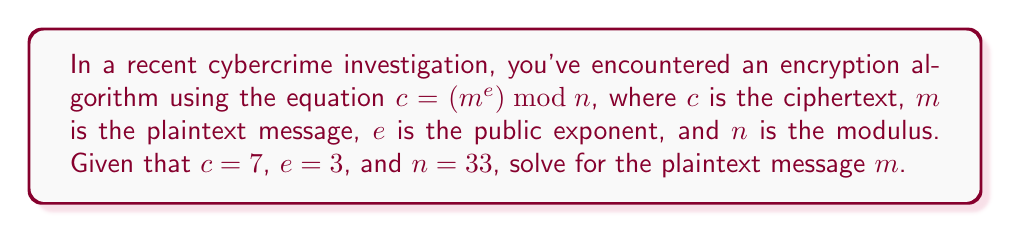Show me your answer to this math problem. To solve for $m$, we need to reverse the encryption process:

1) We start with the equation: $c = (m^e) \bmod n$

2) Substituting the known values:
   $7 = (m^3) \bmod 33$

3) This means that when $m^3$ is divided by 33, the remainder is 7.

4) We need to find a number that, when cubed and divided by 33, leaves a remainder of 7.

5) We can try potential values of $m$ from 1 to 32 (since $n = 33$):

   For $m = 4$:
   $4^3 = 64$
   $64 \div 33 = 1$ remainder $31$

   For $m = 10$:
   $10^3 = 1000$
   $1000 \div 33 = 30$ remainder $10$

   For $m = 13$:
   $13^3 = 2197$
   $2197 \div 33 = 66$ remainder $7$

6) We've found our solution: $m = 13$

7) Verify: $(13^3) \bmod 33 = 2197 \bmod 33 = 7$

Therefore, the plaintext message $m$ is 13.
Answer: $m = 13$ 